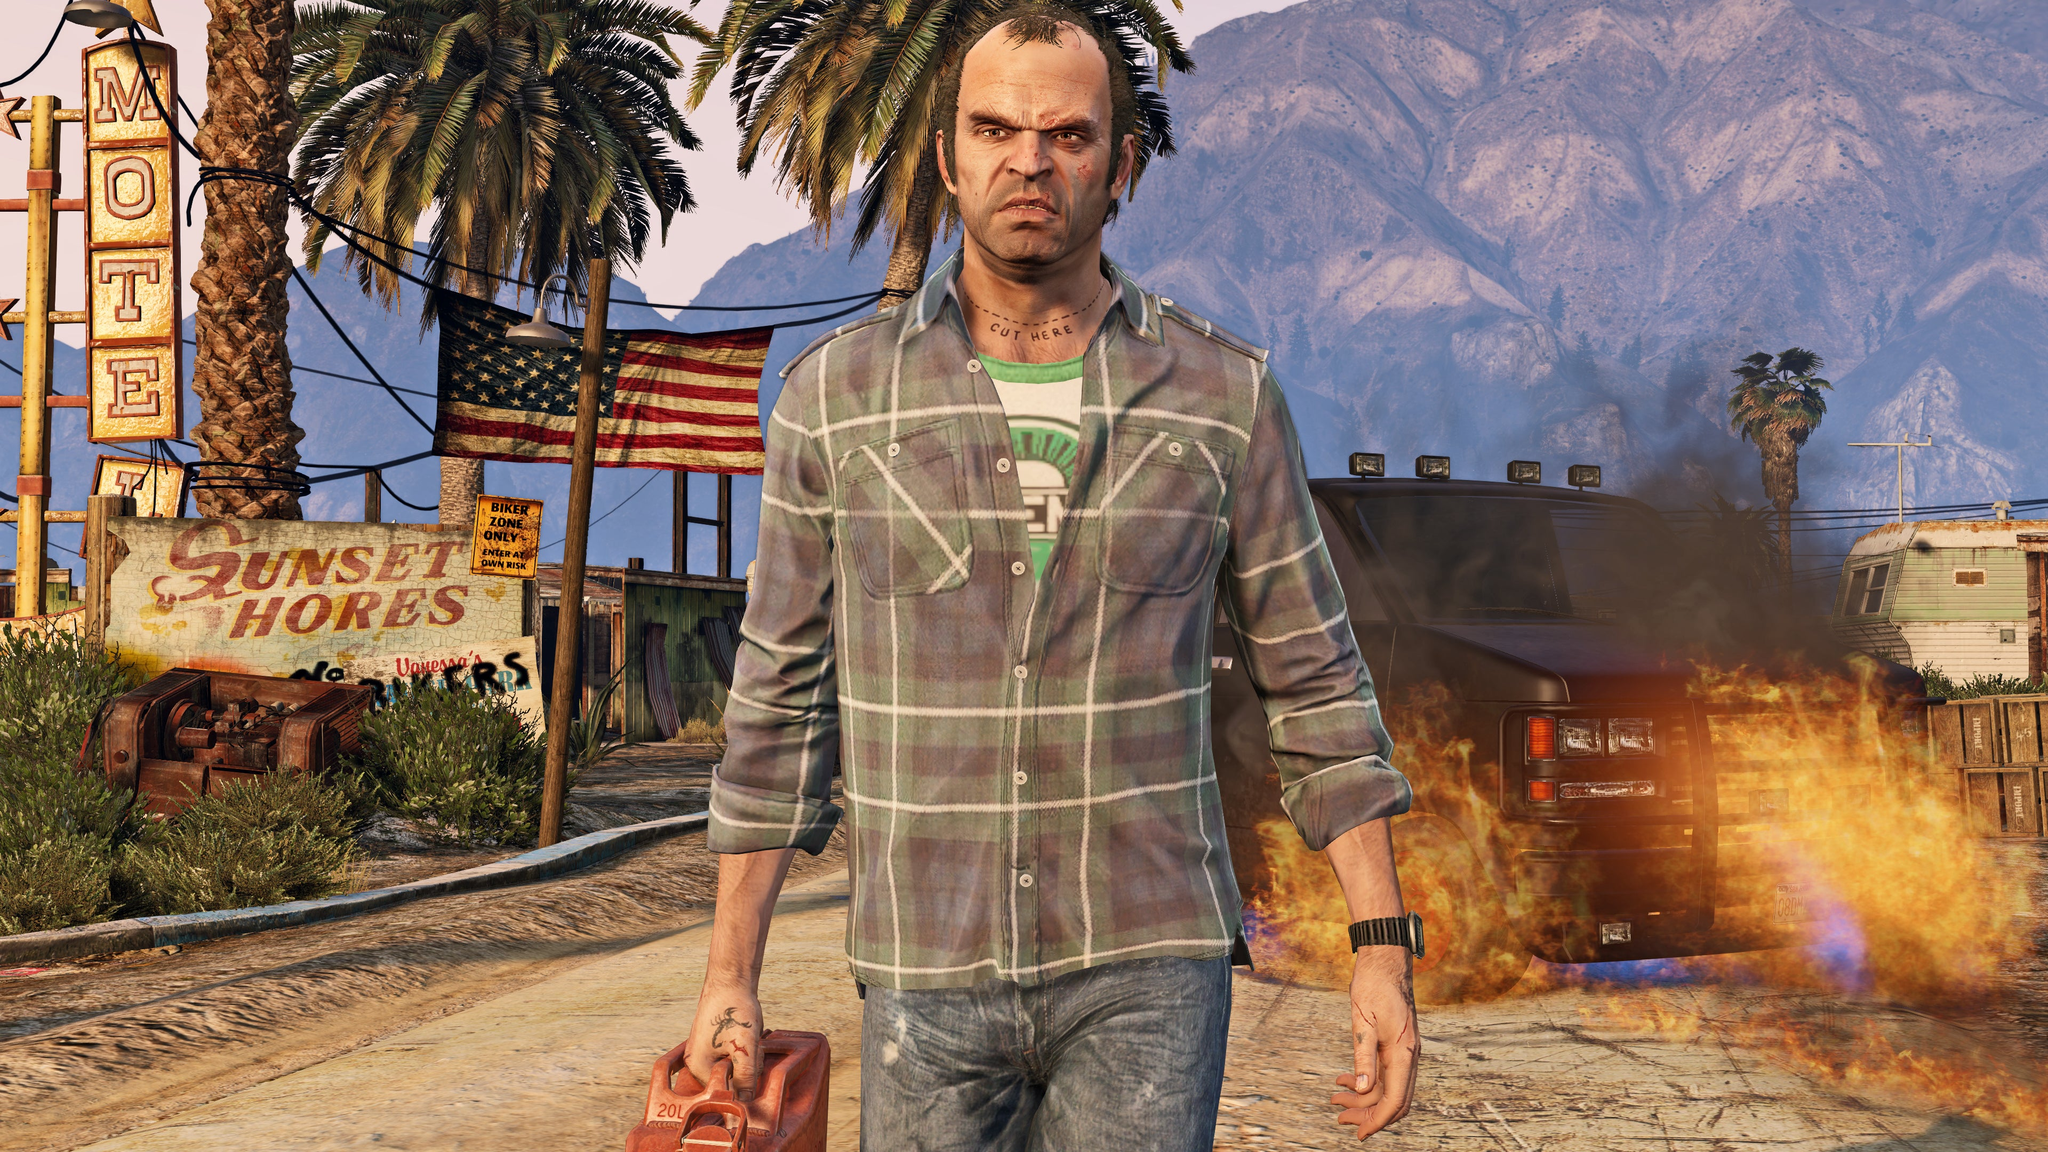Describe a realistic, short scenario involving the person in the image based on the visible details. In a realistic scenario, the man in the foreground is a local resident returning to his childhood town, only to find it in complete disarray. Confronted with the state of the neglected motel and the chaotic scene around him, including the unsupervised fire, he carries a gas can to refuel his empty car. This short visit becomes an emotional journey as he reflects on better times while pondering if he can contribute to reviving the community or if it’s time to move on. 